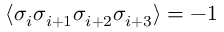Convert formula to latex. <formula><loc_0><loc_0><loc_500><loc_500>\langle \sigma _ { i } \sigma _ { i + 1 } \sigma _ { i + 2 } \sigma _ { i + 3 } \rangle = - 1</formula> 